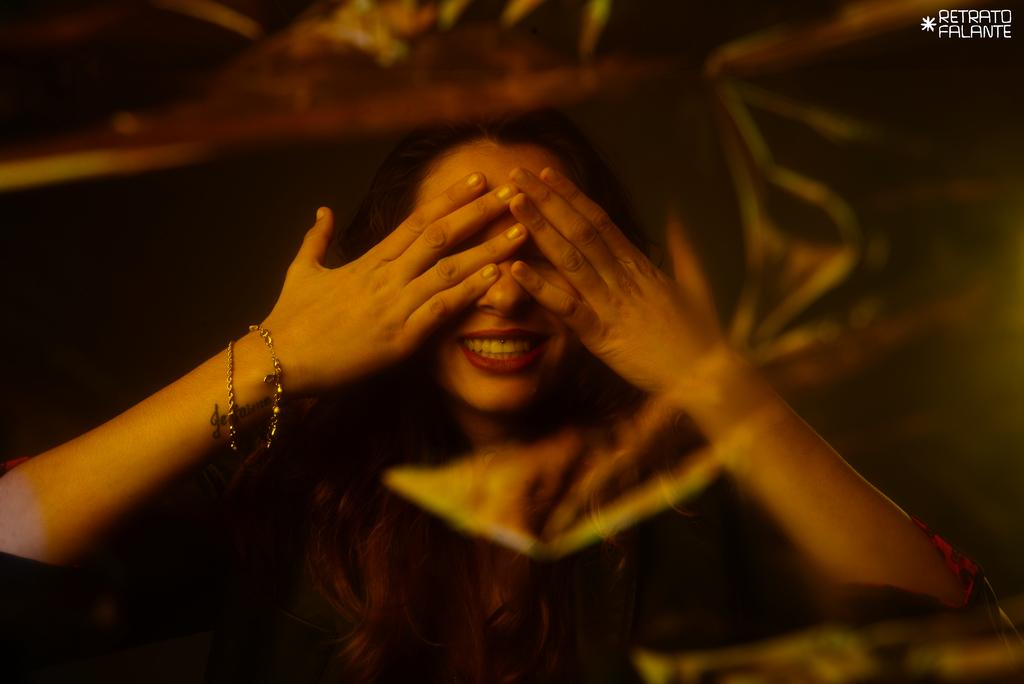Who is present in the image? There is a woman in the image. What is the woman wearing in the image? The woman is wearing accessories in the image. What type of plastic material can be seen in the image? There is no plastic material present in the image. How many tomatoes are visible in the image? There are no tomatoes present in the image. 